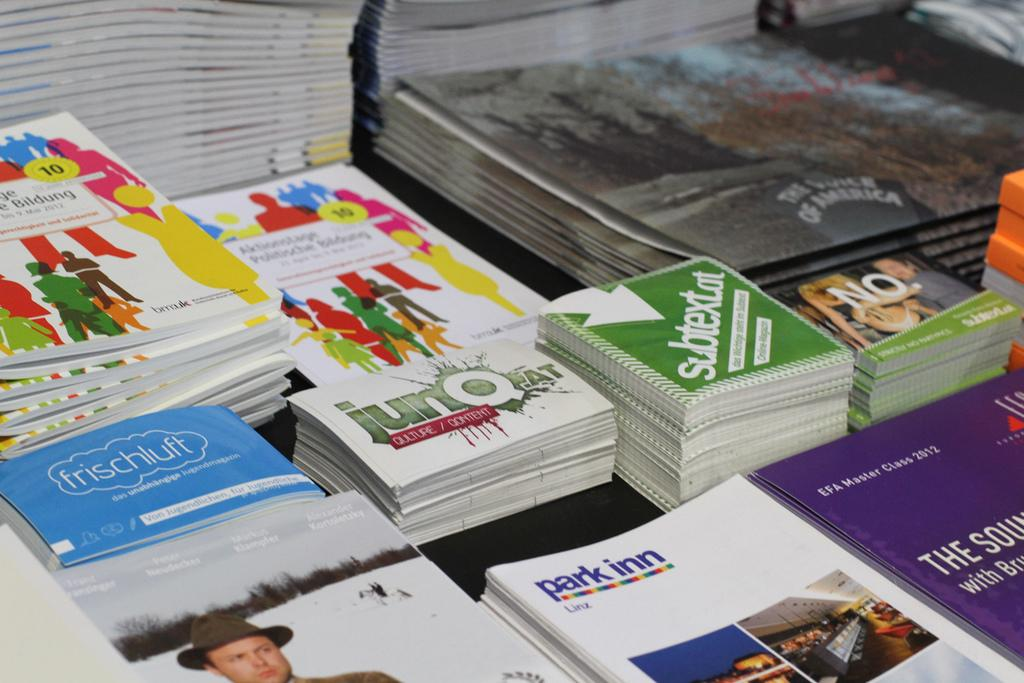<image>
Give a short and clear explanation of the subsequent image. A table is covered with pamphlets from park inn, frischluft, and other things. 